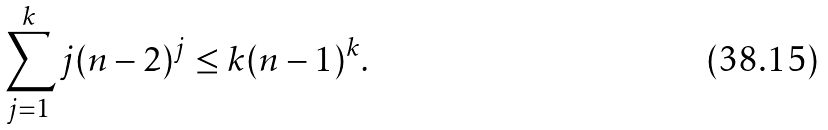Convert formula to latex. <formula><loc_0><loc_0><loc_500><loc_500>\sum _ { j = 1 } ^ { k } j ( n - 2 ) ^ { j } \leq k ( n - 1 ) ^ { k } .</formula> 